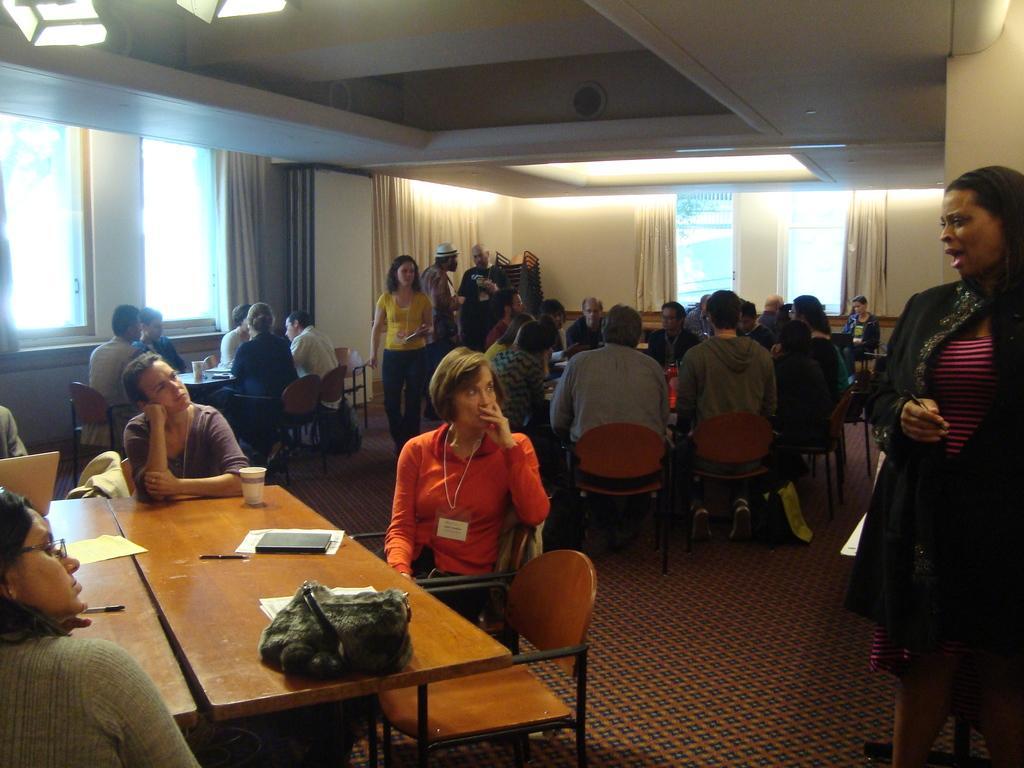Describe this image in one or two sentences. in the picture there are many people sitting on a chair with table in front of them 